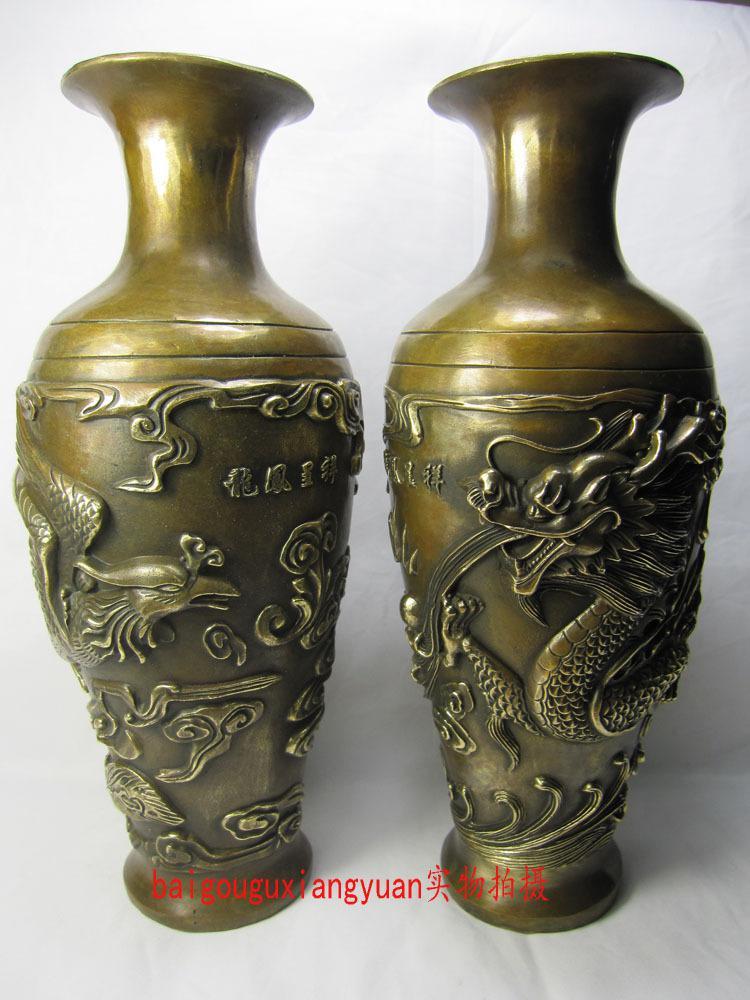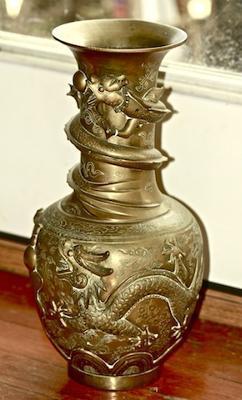The first image is the image on the left, the second image is the image on the right. Analyze the images presented: Is the assertion "There are side handles on the vase." valid? Answer yes or no. No. 